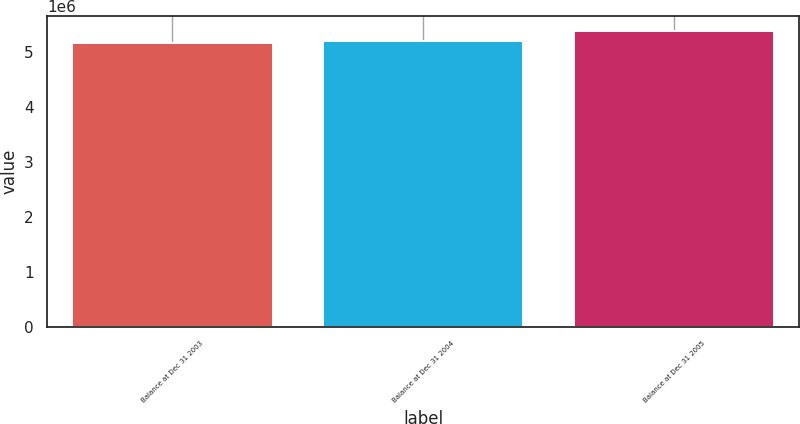Convert chart to OTSL. <chart><loc_0><loc_0><loc_500><loc_500><bar_chart><fcel>Balance at Dec 31 2003<fcel>Balance at Dec 31 2004<fcel>Balance at Dec 31 2005<nl><fcel>5.16644e+06<fcel>5.20292e+06<fcel>5.39526e+06<nl></chart> 